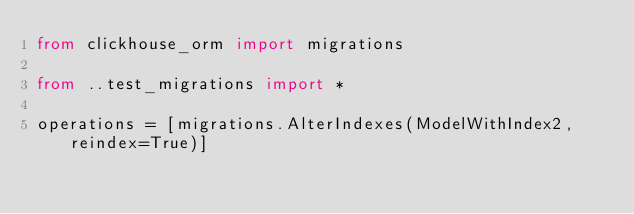Convert code to text. <code><loc_0><loc_0><loc_500><loc_500><_Python_>from clickhouse_orm import migrations

from ..test_migrations import *

operations = [migrations.AlterIndexes(ModelWithIndex2, reindex=True)]
</code> 